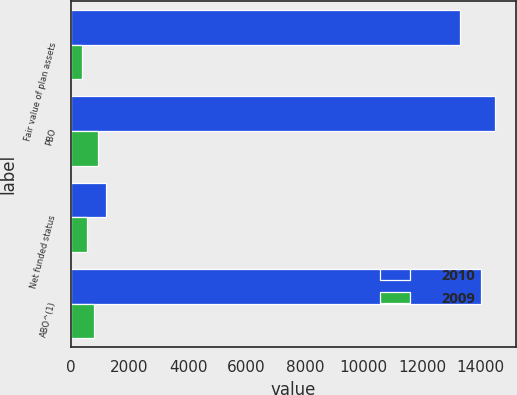<chart> <loc_0><loc_0><loc_500><loc_500><stacked_bar_chart><ecel><fcel>Fair value of plan assets<fcel>PBO<fcel>Net funded status<fcel>ABO^(1)<nl><fcel>2010<fcel>13295<fcel>14484<fcel>1189<fcel>14014<nl><fcel>2009<fcel>375<fcel>923<fcel>548<fcel>778<nl></chart> 